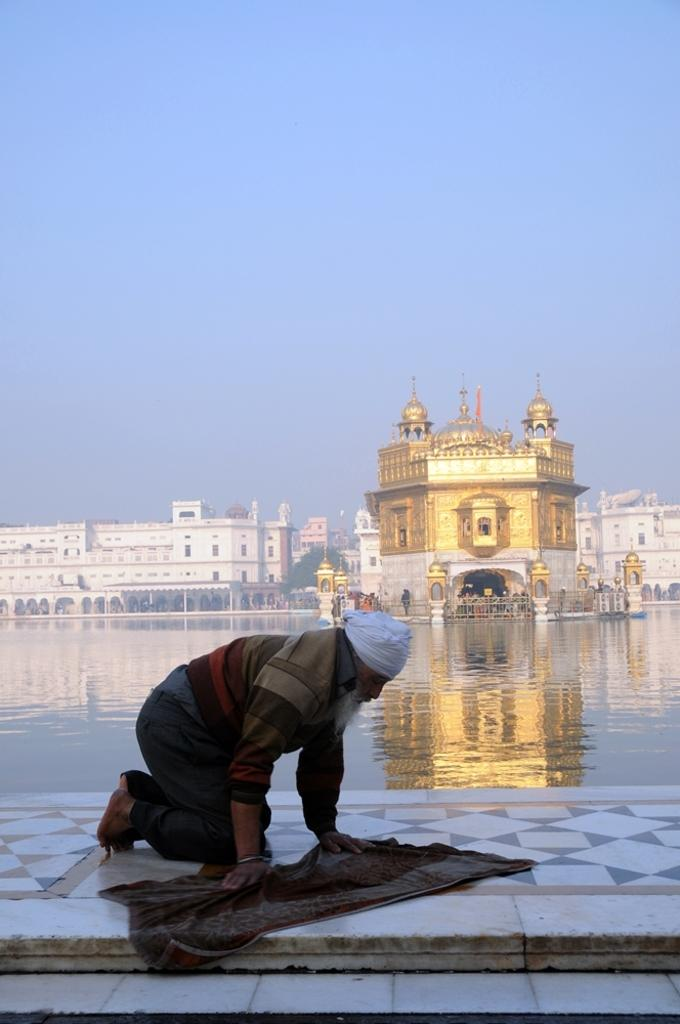What type of water body can be seen in the image? There is a small lake in the image. What is the person in the image doing? The person is in a kneeling position in the image. What type of structure is present in the image? There is a temple in the image. What other types of structures can be seen in the image? There are buildings in the image. What type of vegetation is present in the image? There are trees in the image. What is the person kneeling on in the image? There is a mat in the image. What surface is visible beneath the mat? There is a floor in the image. What type of food is being prepared on the mat in the image? There is no food visible in the image, and the person is not preparing any food. Can you see a dog in the image? There is no dog present in the image. 